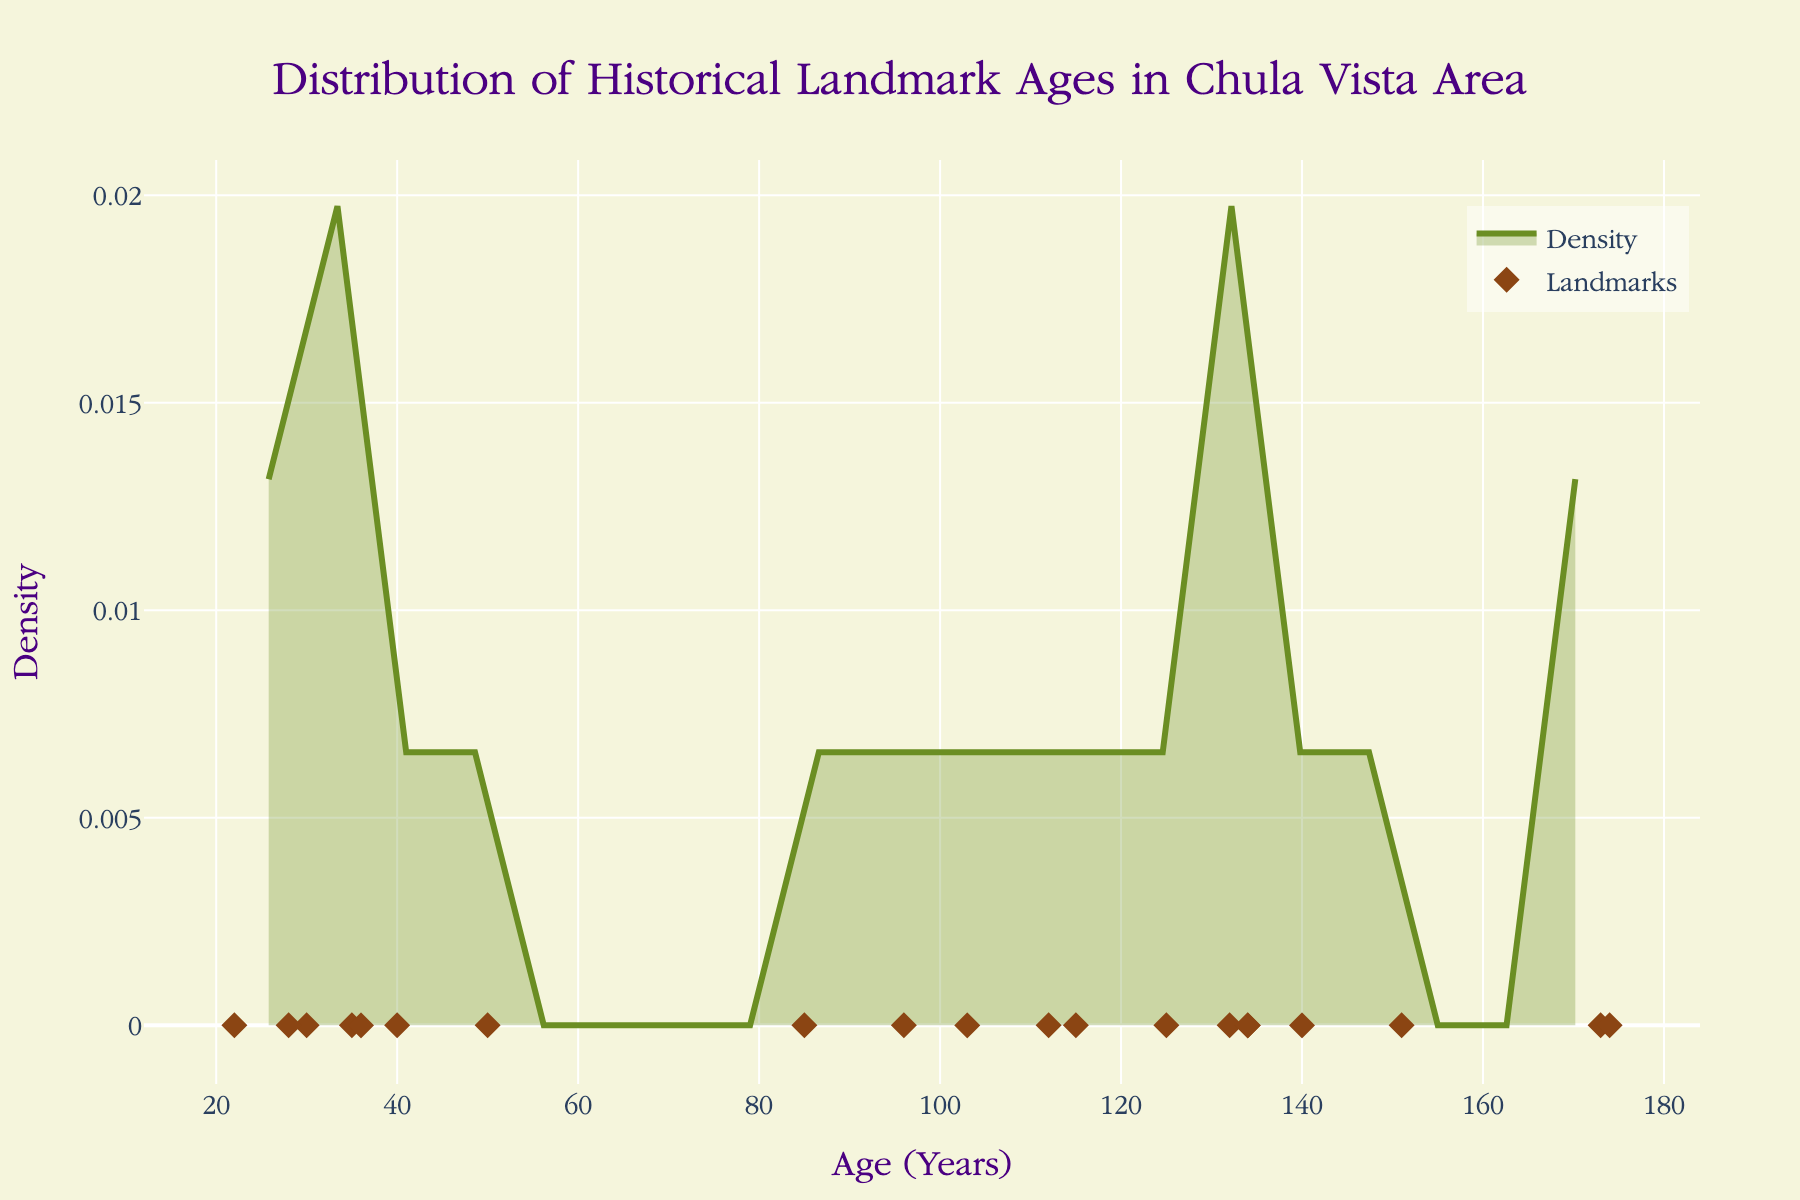What is the title of the plot? The title is prominently displayed at the top of the plot and reads: "Distribution of Historical Landmark Ages in Chula Vista Area".
Answer: Distribution of Historical Landmark Ages in Chula Vista Area How many historical landmarks are displayed in the plot? The number of markers on the x-axis representing individual data points indicates the total number of landmarks. There are 20 markers along the x-axis.
Answer: 20 What is the x-axis labeled as? The x-axis label is "Age (Years)", as indicated below the axis.
Answer: Age (Years) What color is used for the density line in the plot? The density line is drawn in an olive color which matches the description in the code indicating the line is #6B8E23.
Answer: Olive (greenish) Which landmark has the oldest age and what is that age? By noting the data points on the x-axis, the oldest landmark corresponds to an age of 174 years. Referring to the data, it is the Pio Pico State Historic Park.
Answer: Pio Pico State Historic Park, 174 years How does the age distribution trend in the density plot? Observing the density plot, it shows a peak at younger ages, less dense in the middle range, and another peak towards older ages. This suggests a bimodal distribution.
Answer: Bimodal Do more landmarks fall within the age range of 100 to 150 years or below 50 years? By analyzing the density plot and noting the clusters of data points, there are fewer landmarks within the age range of 100 to 150 years compared to those below 50 years.
Answer: Below 50 years What is the median approximate age of the landmarks? The median age is the middle value when the ages are arranged in ascending order. Counting from both ends, the median falls between the 10th and 11th data points which are roughly around 103 and 105 years.
Answer: Approximately 105 years Compare the age density of landmarks between 0-50 years and 50-100 years. Which range has higher density? By viewing the density curve, the 0-50 years range shows higher density (higher peak) compared to the 50-100 years range.
Answer: 0-50 years How does the density near the landmark with age 40 years compare to age 150 years? The density plot shows a higher density (taller curve) around the age of 40 years compared to the age of 150 years, indicating more landmarks around 40 years than 150 years.
Answer: Higher density at 40 years 